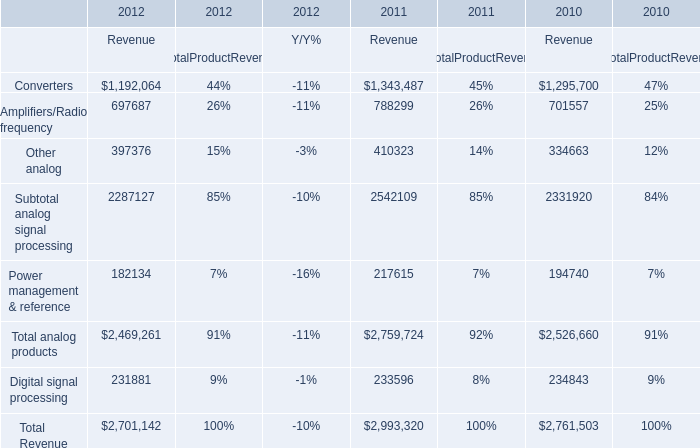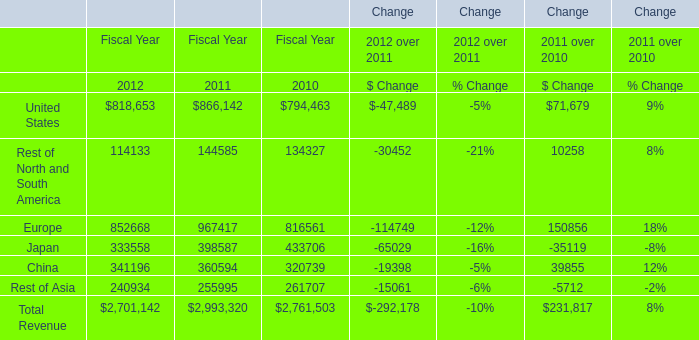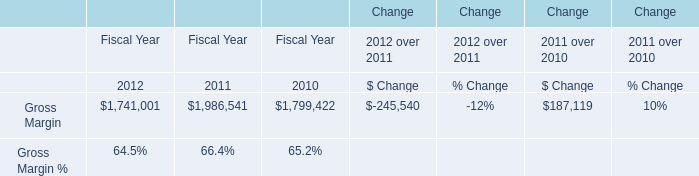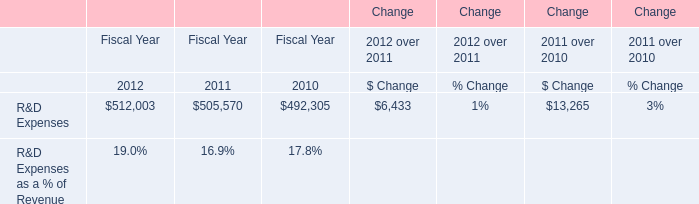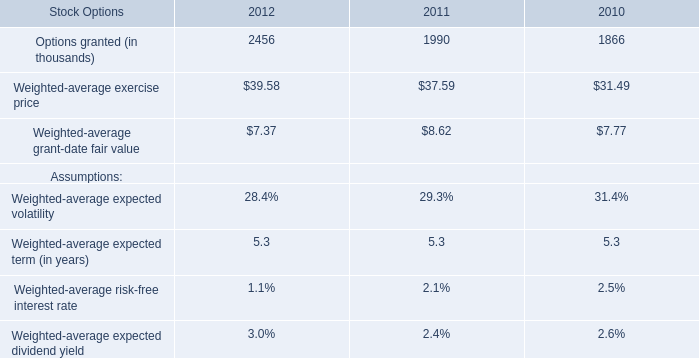In the year with the most Europe in table 1, what is the growth rate of United States in table 1? 
Computations: ((866142 - 794463) / 794463)
Answer: 0.09022. 